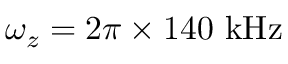Convert formula to latex. <formula><loc_0><loc_0><loc_500><loc_500>\omega _ { z } = 2 \pi \times 1 4 0 { k H z }</formula> 